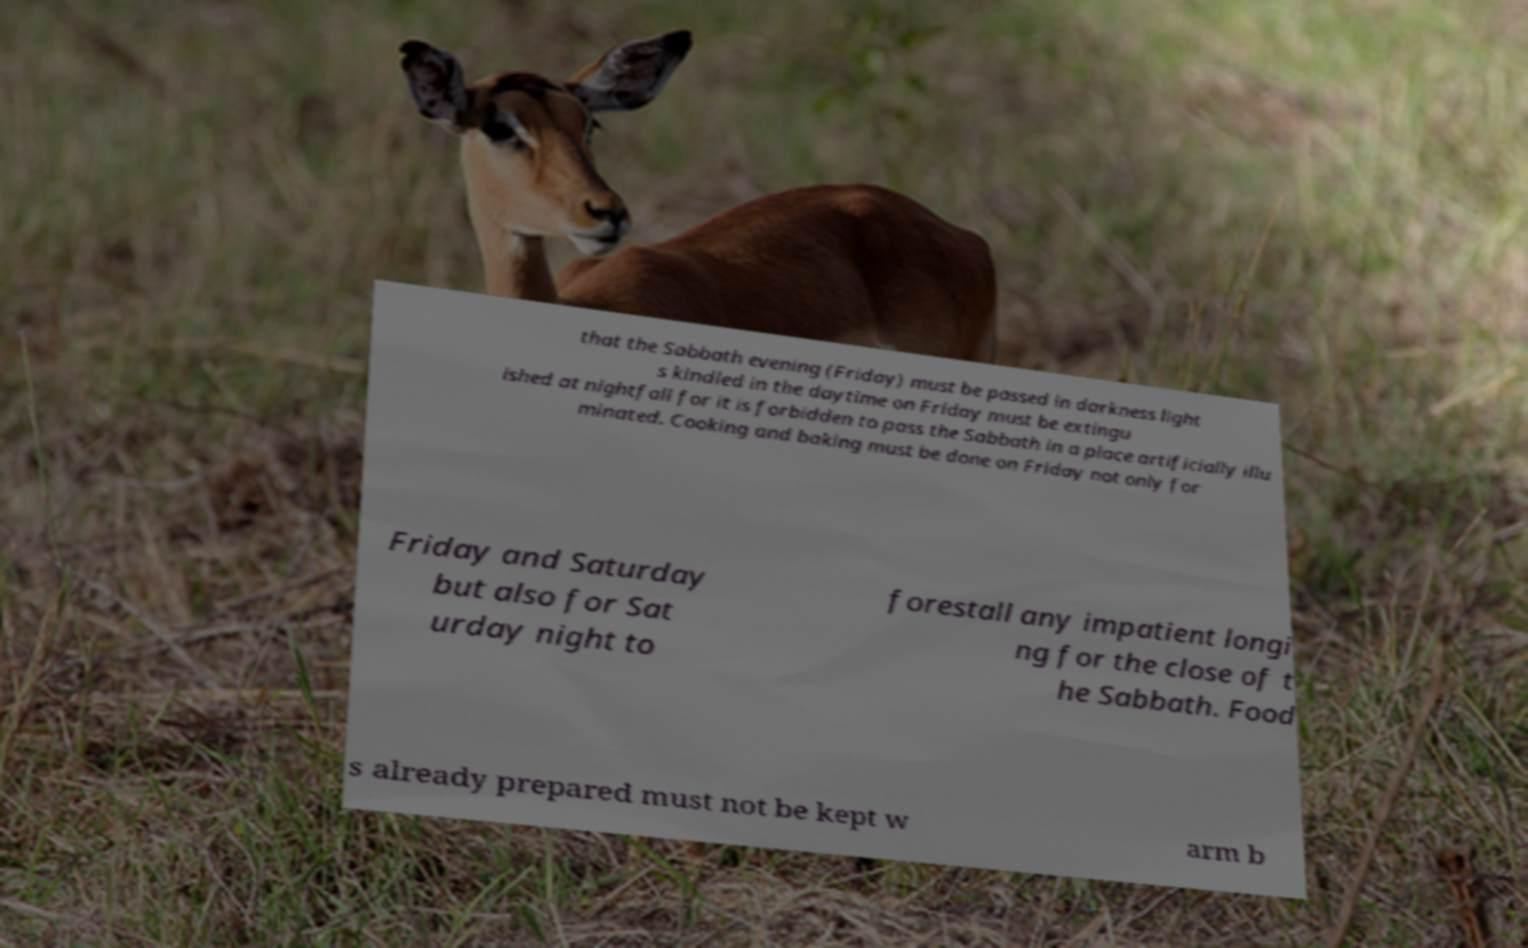Could you extract and type out the text from this image? that the Sabbath evening (Friday) must be passed in darkness light s kindled in the daytime on Friday must be extingu ished at nightfall for it is forbidden to pass the Sabbath in a place artificially illu minated. Cooking and baking must be done on Friday not only for Friday and Saturday but also for Sat urday night to forestall any impatient longi ng for the close of t he Sabbath. Food s already prepared must not be kept w arm b 